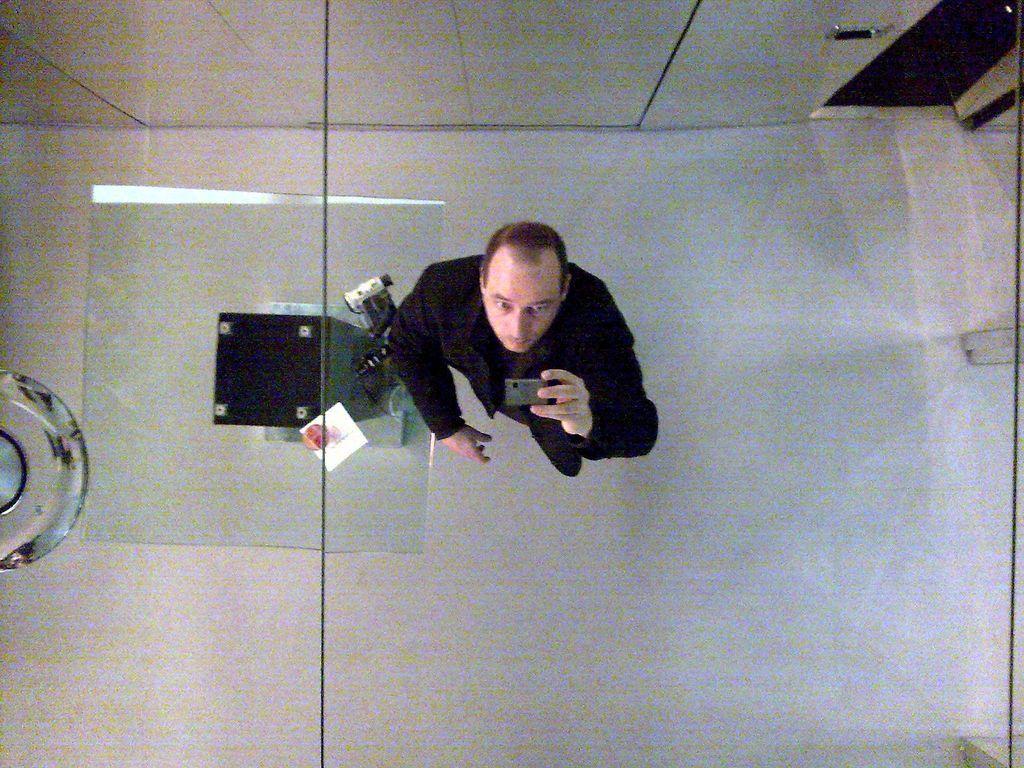Can you describe this image briefly? In the image there is a person taking the picture of the roof, behind the man there is a room on the right side. 